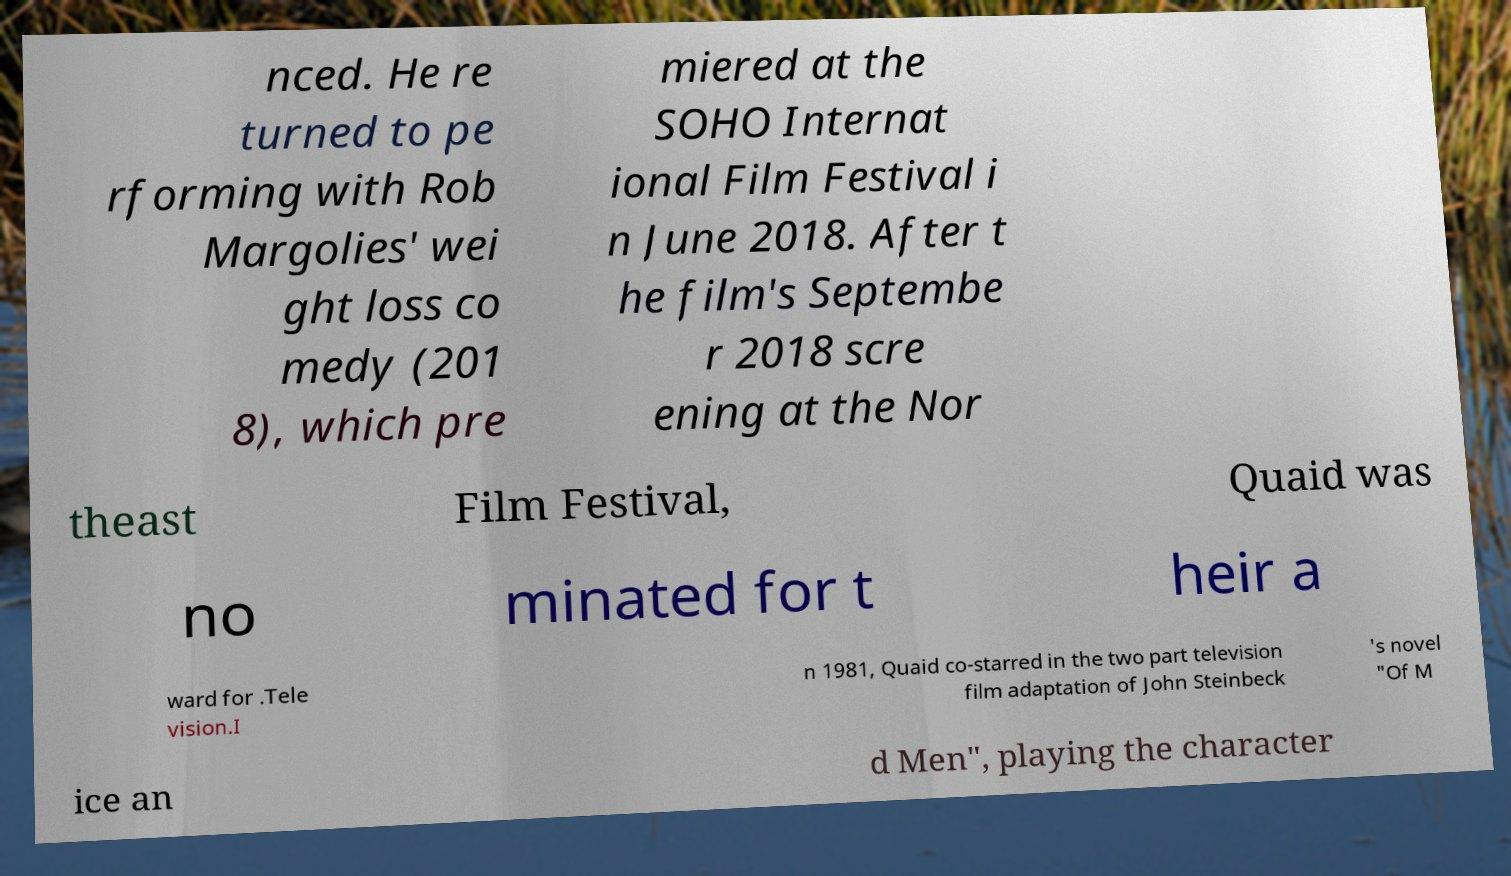There's text embedded in this image that I need extracted. Can you transcribe it verbatim? nced. He re turned to pe rforming with Rob Margolies' wei ght loss co medy (201 8), which pre miered at the SOHO Internat ional Film Festival i n June 2018. After t he film's Septembe r 2018 scre ening at the Nor theast Film Festival, Quaid was no minated for t heir a ward for .Tele vision.I n 1981, Quaid co-starred in the two part television film adaptation of John Steinbeck 's novel "Of M ice an d Men", playing the character 